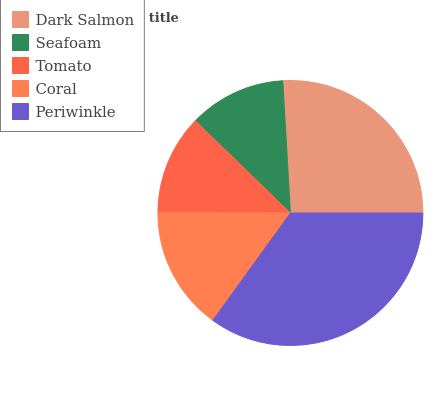Is Seafoam the minimum?
Answer yes or no. Yes. Is Periwinkle the maximum?
Answer yes or no. Yes. Is Tomato the minimum?
Answer yes or no. No. Is Tomato the maximum?
Answer yes or no. No. Is Tomato greater than Seafoam?
Answer yes or no. Yes. Is Seafoam less than Tomato?
Answer yes or no. Yes. Is Seafoam greater than Tomato?
Answer yes or no. No. Is Tomato less than Seafoam?
Answer yes or no. No. Is Coral the high median?
Answer yes or no. Yes. Is Coral the low median?
Answer yes or no. Yes. Is Periwinkle the high median?
Answer yes or no. No. Is Seafoam the low median?
Answer yes or no. No. 